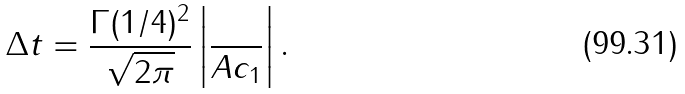Convert formula to latex. <formula><loc_0><loc_0><loc_500><loc_500>\Delta t = \frac { \Gamma ( 1 / 4 ) ^ { 2 } } { \sqrt { 2 \pi } } \left | \frac { } { A c _ { 1 } } \right | .</formula> 